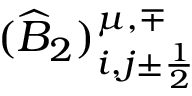Convert formula to latex. <formula><loc_0><loc_0><loc_500><loc_500>( \widehat { B } _ { 2 } ) _ { i , j \pm \frac { 1 } { 2 } } ^ { \mu , \mp }</formula> 